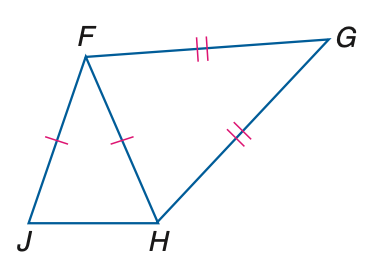Answer the mathemtical geometry problem and directly provide the correct option letter.
Question: In the figure, F J \cong F H and G F \cong G H. If m \angle J F H = 34, find m \angle J.
Choices: A: 34 B: 73 C: 112 D: 146 B 